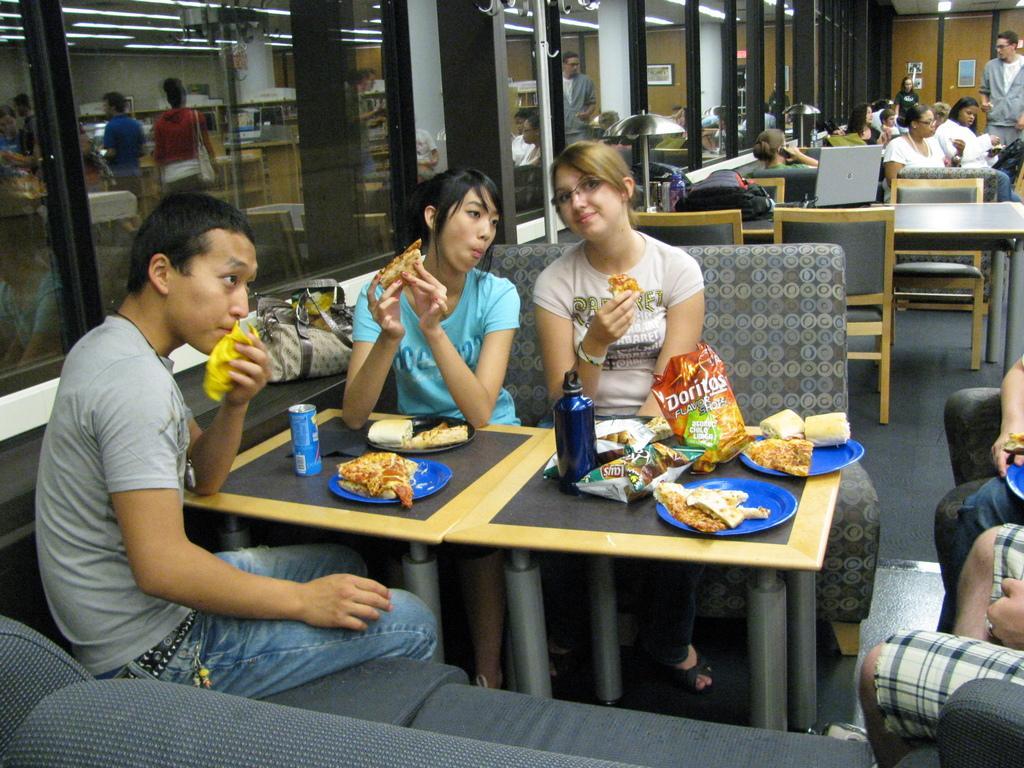In one or two sentences, can you explain what this image depicts? In this image I can see three people are sitting on the sofa around the table. On the table there are some food items, plate coke-tin and bottles. This is an image clicked inside the hall. In the background there are few more tables and persons sitting on the chairs. There is one laptop and one bag is there on one table. 